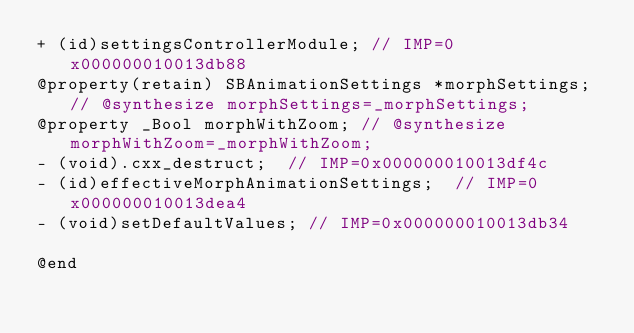<code> <loc_0><loc_0><loc_500><loc_500><_C_>+ (id)settingsControllerModule;	// IMP=0x000000010013db88
@property(retain) SBAnimationSettings *morphSettings; // @synthesize morphSettings=_morphSettings;
@property _Bool morphWithZoom; // @synthesize morphWithZoom=_morphWithZoom;
- (void).cxx_destruct;	// IMP=0x000000010013df4c
- (id)effectiveMorphAnimationSettings;	// IMP=0x000000010013dea4
- (void)setDefaultValues;	// IMP=0x000000010013db34

@end

</code> 